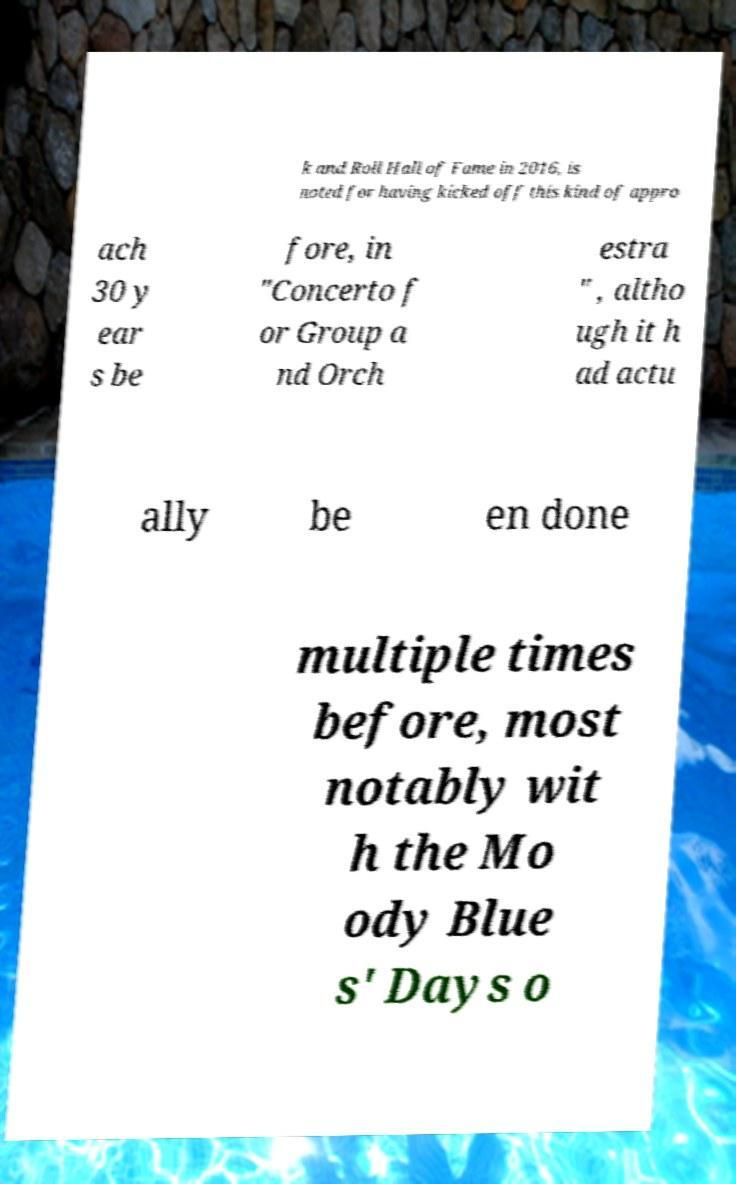There's text embedded in this image that I need extracted. Can you transcribe it verbatim? k and Roll Hall of Fame in 2016, is noted for having kicked off this kind of appro ach 30 y ear s be fore, in "Concerto f or Group a nd Orch estra " , altho ugh it h ad actu ally be en done multiple times before, most notably wit h the Mo ody Blue s' Days o 